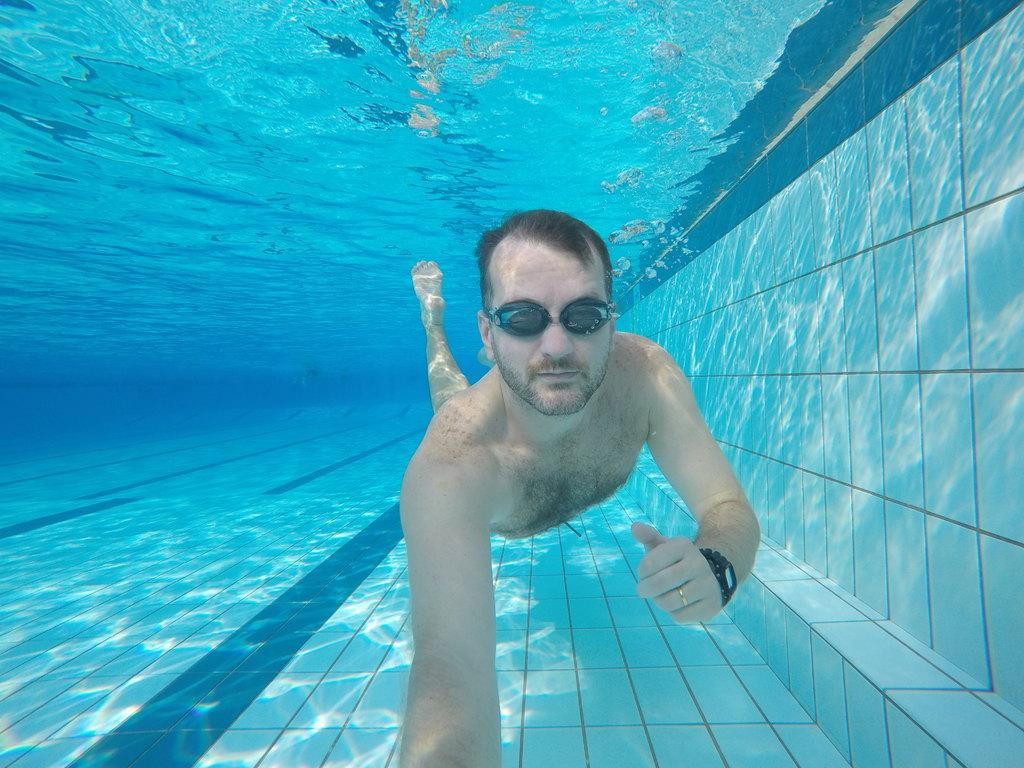What is the person in the image doing? There is a person swimming in the image. What can be seen in the background of the image? There is a wall visible in the image. What is the primary element in which the person is swimming? There is water visible in the image. What type of table is floating on the water in the image? There is no table present in the image; it features a person swimming in water with a wall visible in the background. 